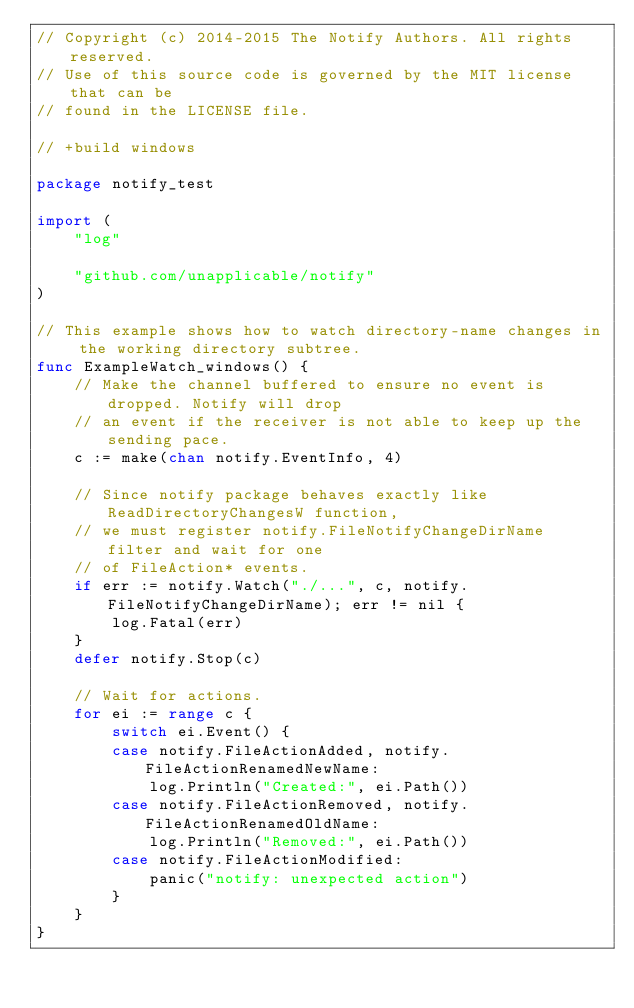Convert code to text. <code><loc_0><loc_0><loc_500><loc_500><_Go_>// Copyright (c) 2014-2015 The Notify Authors. All rights reserved.
// Use of this source code is governed by the MIT license that can be
// found in the LICENSE file.

// +build windows

package notify_test

import (
	"log"

	"github.com/unapplicable/notify"
)

// This example shows how to watch directory-name changes in the working directory subtree.
func ExampleWatch_windows() {
	// Make the channel buffered to ensure no event is dropped. Notify will drop
	// an event if the receiver is not able to keep up the sending pace.
	c := make(chan notify.EventInfo, 4)

	// Since notify package behaves exactly like ReadDirectoryChangesW function,
	// we must register notify.FileNotifyChangeDirName filter and wait for one
	// of FileAction* events.
	if err := notify.Watch("./...", c, notify.FileNotifyChangeDirName); err != nil {
		log.Fatal(err)
	}
	defer notify.Stop(c)

	// Wait for actions.
	for ei := range c {
		switch ei.Event() {
		case notify.FileActionAdded, notify.FileActionRenamedNewName:
			log.Println("Created:", ei.Path())
		case notify.FileActionRemoved, notify.FileActionRenamedOldName:
			log.Println("Removed:", ei.Path())
		case notify.FileActionModified:
			panic("notify: unexpected action")
		}
	}
}
</code> 